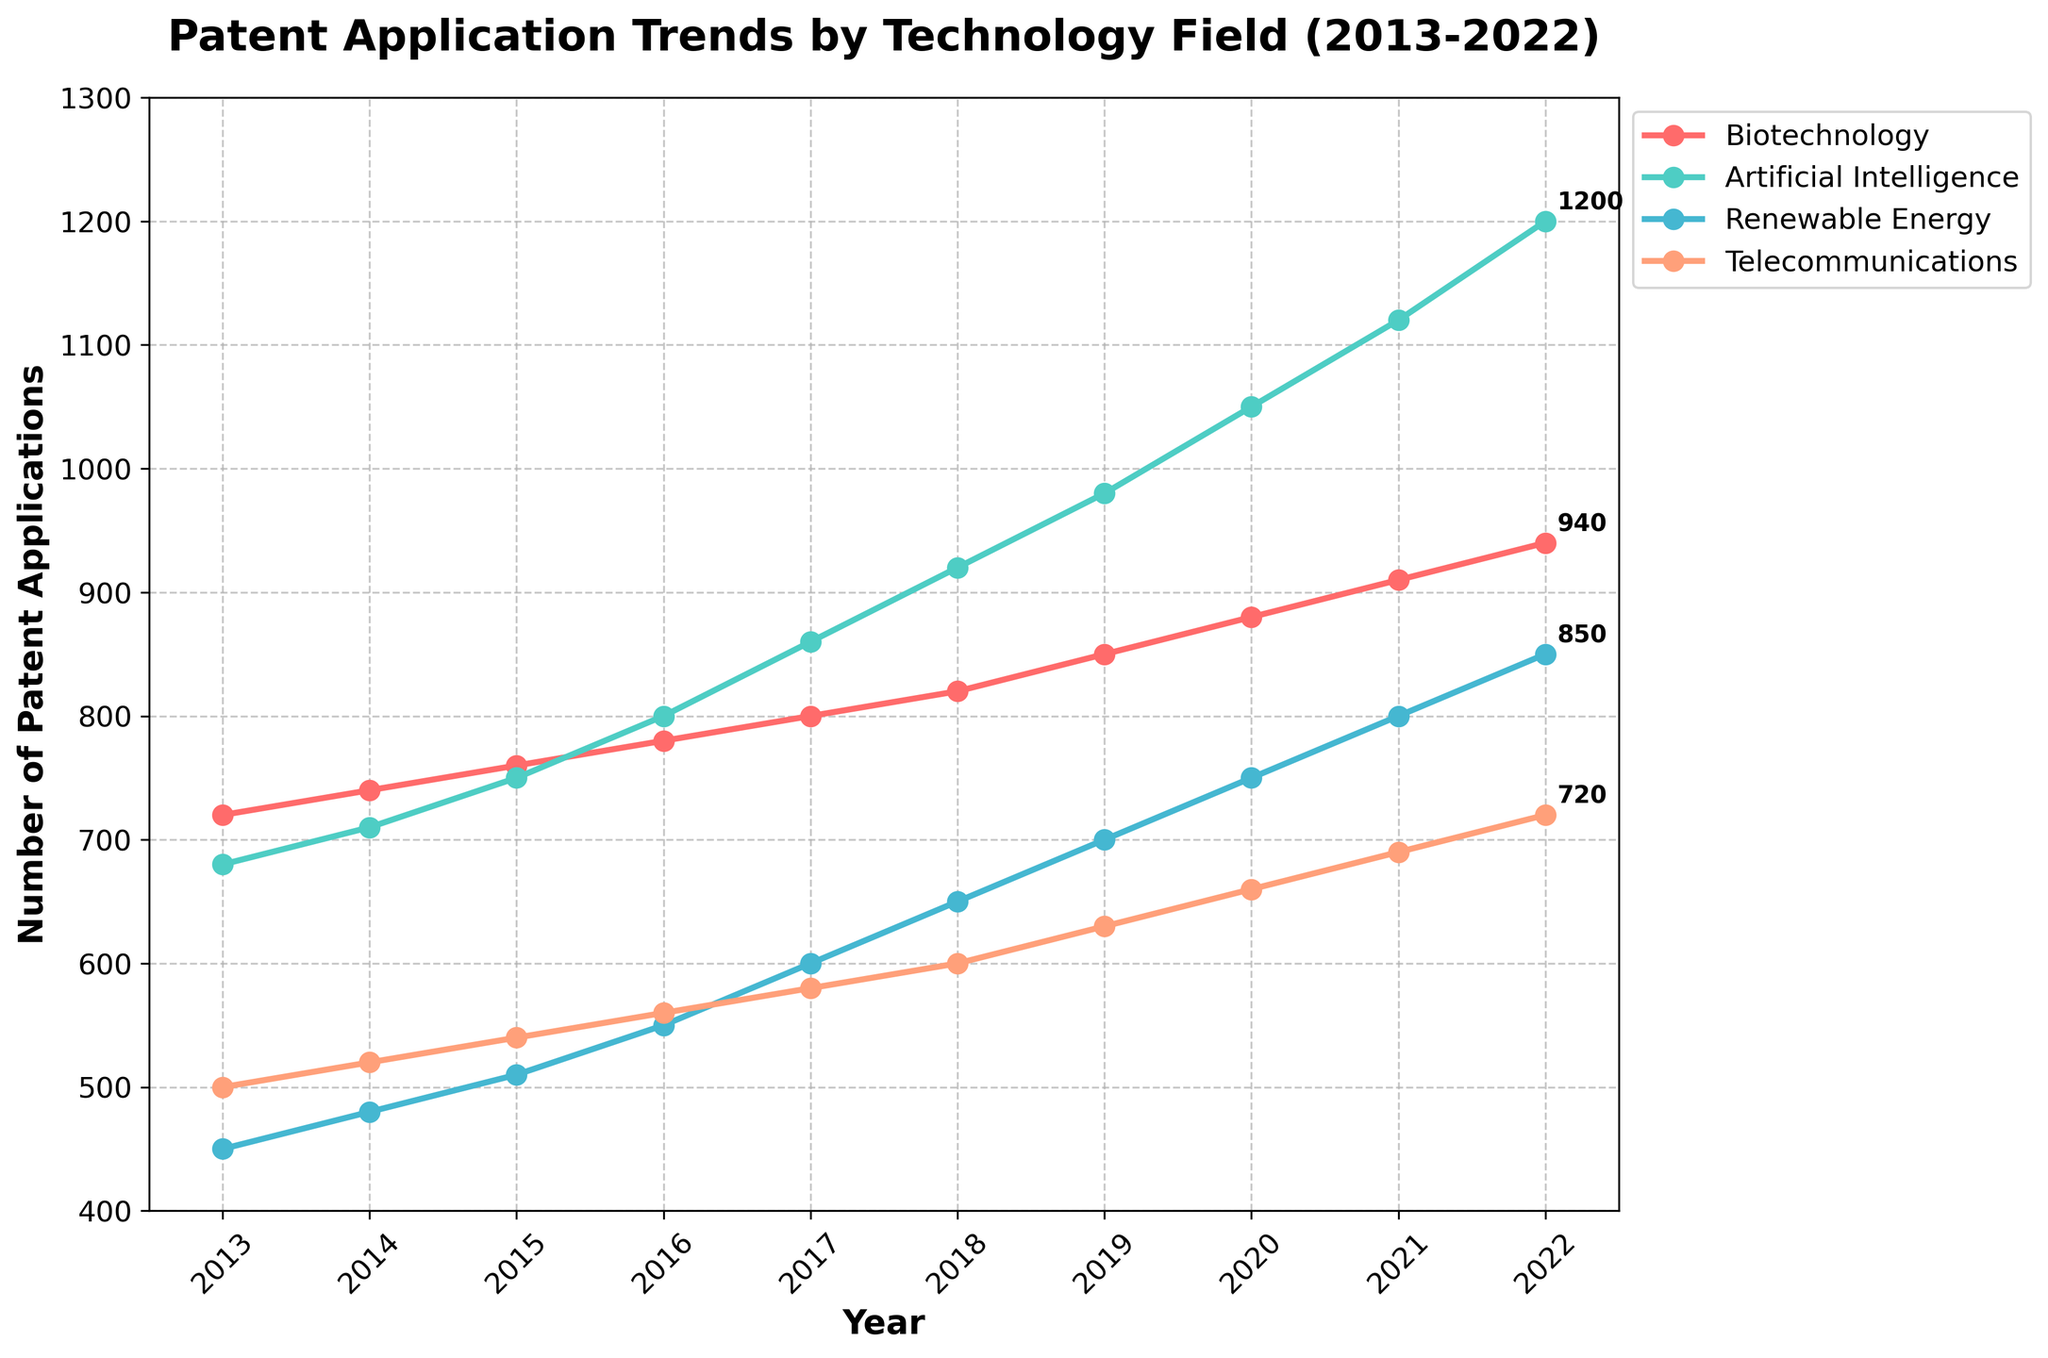How many different technology fields are displayed in the plot? The plot has a legend that shows the different technology fields being tracked. By counting the number of distinct entries in the legend, we can determine the number of technology fields.
Answer: 4 Which technology field had the highest number of patent applications in 2022? By looking at the data points at the far right end of the plot (the year 2022) and comparing their values, we can see which line reaches the highest point. The label can be found in the legend.
Answer: Artificial Intelligence What trend do you observe for patent applications in Renewable Energy over the past decade? By following the line representing Renewable Energy from 2013 to 2022, we observe a steady increase in the number of patent applications over the years.
Answer: Steady increase Between which years did the number of patent applications in Biotechnology experience the largest increase? By examining the line for Biotechnology and comparing the year-to-year changes, we identify the years where the rise is the most significant. Specifically, look for the steepest incline.
Answer: 2021 to 2022 In which year did Telecommunications see the lowest number of patent applications? By identifying the lowest point on the Telecommunications line and noting the corresponding year on the x-axis, we find the minimum value.
Answer: 2013 How does the trend of patent applications in Artificial Intelligence compare with that in Biotechnology? We should compare the slopes (steepness) and overall direction (increase, decrease, or stable) of the lines representing Artificial Intelligence and Biotechnology over the years.
Answer: AI shows a steeper increase than Biotechnology What is the average number of patent applications for Telecommunications across the years presented? To find the average, we sum up the number of patent applications for each year for Telecommunications and divide by the number of years. E.g., (500 + 520 + 540 + 560 + 580 + 600 + 630 + 660 + 690 + 720) / 10 = 600
Answer: 600 Which technology field showed the least variability in the number of patent applications over the decade? By inspecting the plots, the technology field with the flattest line or smallest fluctuation indicates the least variability.
Answer: Telecommunications In 2016, which technology field had more patent applications, Renewable Energy or Artificial Intelligence? Looking at the data points for 2016, we compare the number of patent applications for Renewable Energy and Artificial Intelligence.
Answer: Artificial Intelligence What was the median number of patent applications for Biotechnology from 2013 to 2022? To find the median, we first list all values for Biotechnology, arrange them in ascending order, and determine the middle value. Values: [720, 740, 760, 780, 800, 820, 850, 880, 910, 940], the median is the average of the 5th and 6th values in this ordered list, (800+820)/2.
Answer: 810 